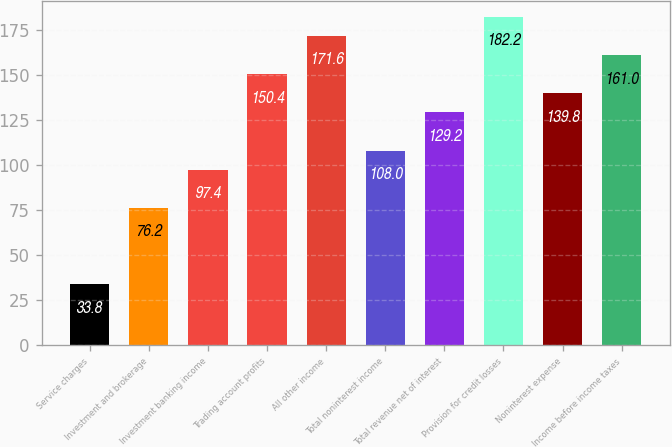<chart> <loc_0><loc_0><loc_500><loc_500><bar_chart><fcel>Service charges<fcel>Investment and brokerage<fcel>Investment banking income<fcel>Trading account profits<fcel>All other income<fcel>Total noninterest income<fcel>Total revenue net of interest<fcel>Provision for credit losses<fcel>Noninterest expense<fcel>Income before income taxes<nl><fcel>33.8<fcel>76.2<fcel>97.4<fcel>150.4<fcel>171.6<fcel>108<fcel>129.2<fcel>182.2<fcel>139.8<fcel>161<nl></chart> 